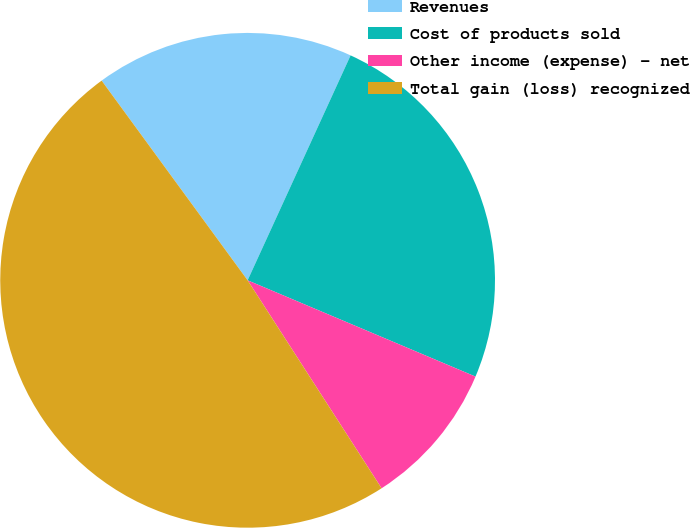Convert chart to OTSL. <chart><loc_0><loc_0><loc_500><loc_500><pie_chart><fcel>Revenues<fcel>Cost of products sold<fcel>Other income (expense) - net<fcel>Total gain (loss) recognized<nl><fcel>16.88%<fcel>24.53%<fcel>9.53%<fcel>49.06%<nl></chart> 